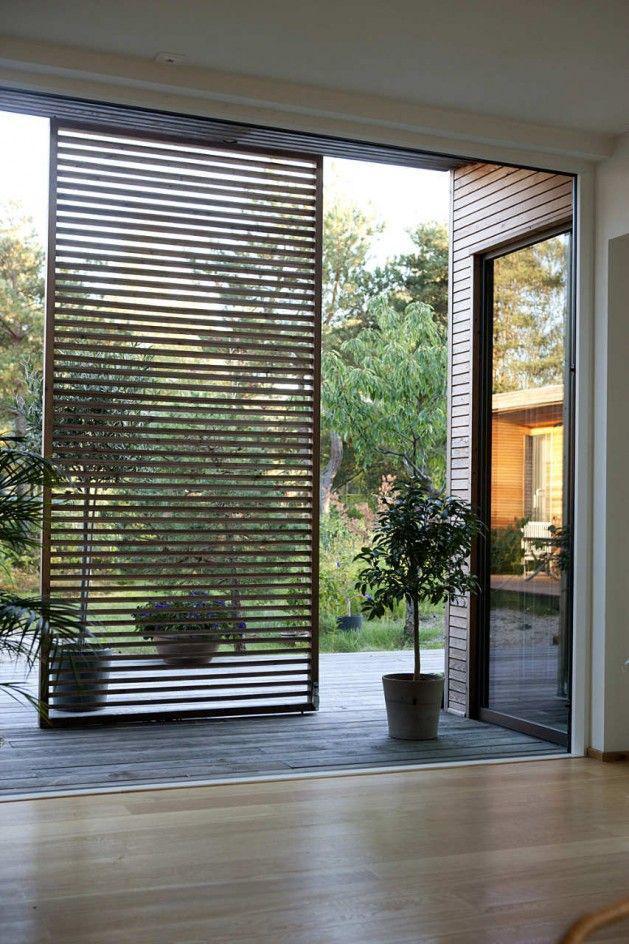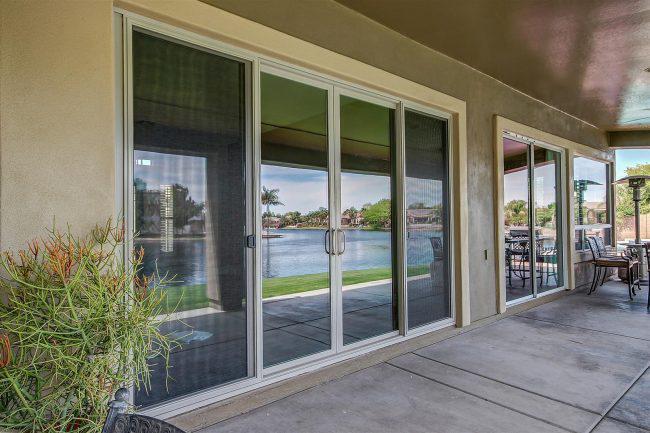The first image is the image on the left, the second image is the image on the right. Analyze the images presented: Is the assertion "There are six glass panes in a row in the right image." valid? Answer yes or no. Yes. 